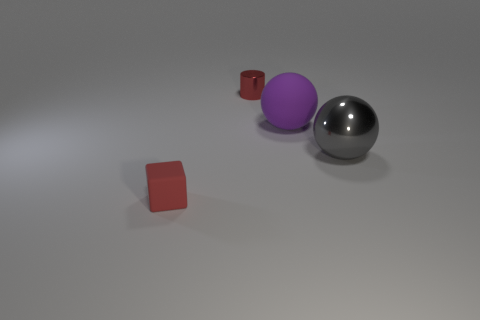How would you describe the light source in this scene? The light source in this image appears to be positioned above the scene, casting soft shadows directly underneath the objects. It provides a diffused lighting effect, eliminating harsh shadows, and contributing to the gentle ambiance of the image. 